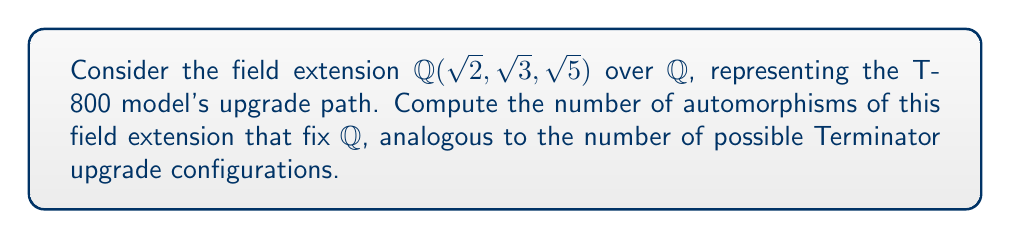Could you help me with this problem? Let's approach this step-by-step:

1) First, we need to understand the structure of the field extension. $\mathbb{Q}(\sqrt{2}, \sqrt{3}, \sqrt{5})$ is obtained by adjoining $\sqrt{2}$, $\sqrt{3}$, and $\sqrt{5}$ to $\mathbb{Q}$.

2) The degree of this extension is:
   $$[\mathbb{Q}(\sqrt{2}, \sqrt{3}, \sqrt{5}):\mathbb{Q}] = 8$$
   This is because $\sqrt{2}$, $\sqrt{3}$, and $\sqrt{5}$ are independent over $\mathbb{Q}$.

3) Any automorphism $\sigma$ of this field extension that fixes $\mathbb{Q}$ must send each $\sqrt{p}$ (where $p = 2, 3, 5$) to either $\sqrt{p}$ or $-\sqrt{p}$. This is because $\sigma(\sqrt{p})^2 = \sigma(p) = p$.

4) For each $\sqrt{p}$, we have two choices. Since there are three such square roots, we have $2^3 = 8$ possible automorphisms.

5) We can represent these automorphisms as:
   $$\sigma_{ijk}(\sqrt{2}, \sqrt{3}, \sqrt{5}) = ((-1)^i\sqrt{2}, (-1)^j\sqrt{3}, (-1)^k\sqrt{5})$$
   where $i, j, k \in \{0, 1\}$.

6) These 8 automorphisms form a group isomorphic to $(\mathbb{Z}/2\mathbb{Z})^3$, representing the possible "upgrade configurations" of our T-800 model.
Answer: 8 